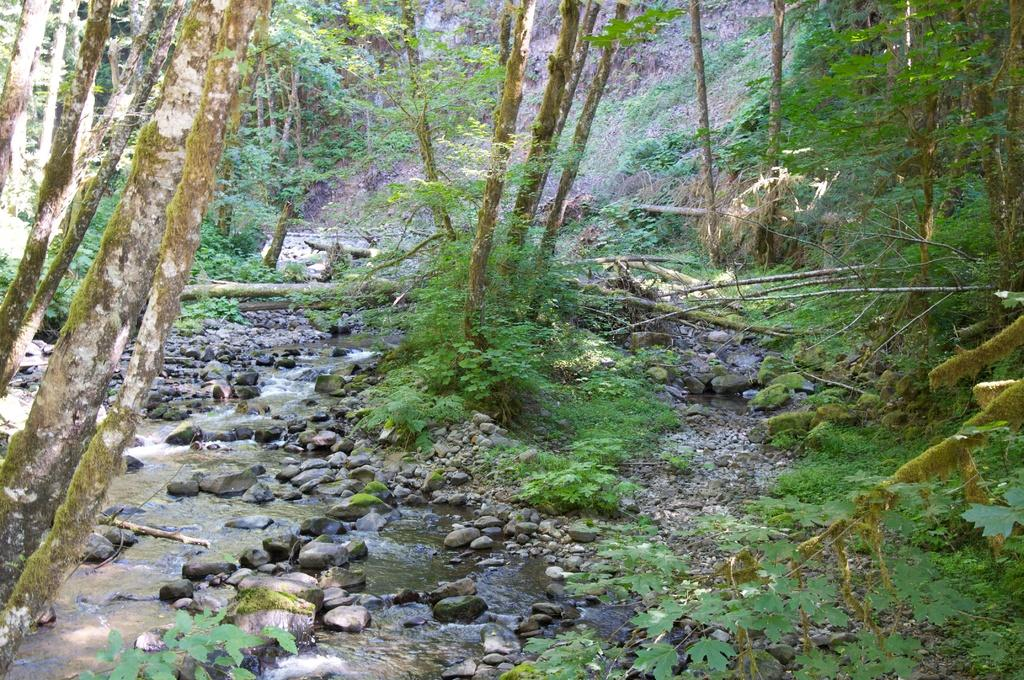What is the primary element visible in the image? There is water in the image. What other objects or features can be seen in the image? There are rocks and trees present in the image. What type of gun can be seen in the image? There is no gun present in the image. How many chickens are visible in the image? There are no chickens present in the image. 